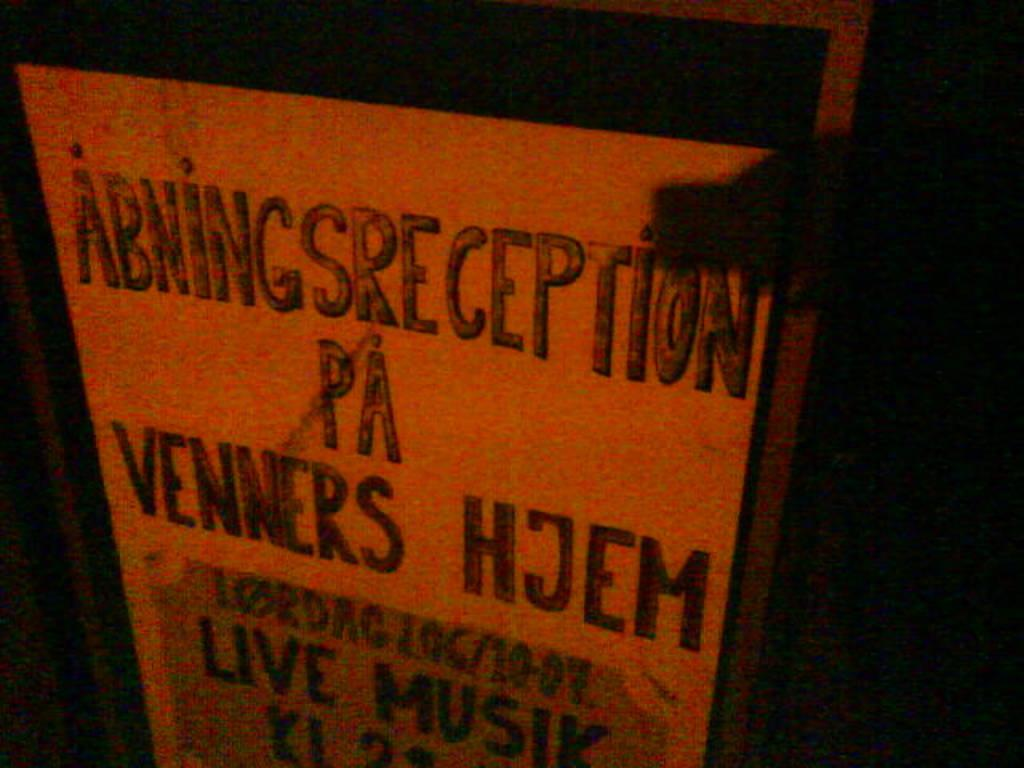<image>
Render a clear and concise summary of the photo. a sign that has the word venners on it 